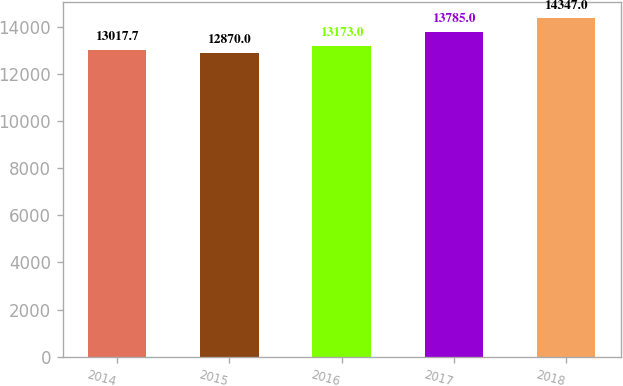Convert chart to OTSL. <chart><loc_0><loc_0><loc_500><loc_500><bar_chart><fcel>2014<fcel>2015<fcel>2016<fcel>2017<fcel>2018<nl><fcel>13017.7<fcel>12870<fcel>13173<fcel>13785<fcel>14347<nl></chart> 